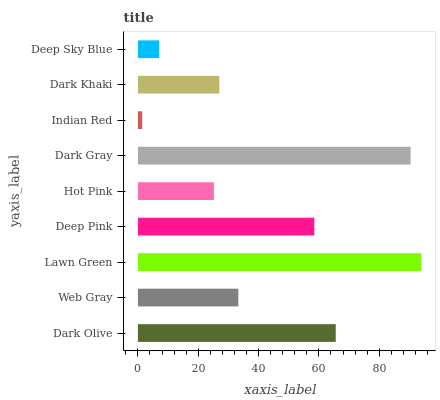Is Indian Red the minimum?
Answer yes or no. Yes. Is Lawn Green the maximum?
Answer yes or no. Yes. Is Web Gray the minimum?
Answer yes or no. No. Is Web Gray the maximum?
Answer yes or no. No. Is Dark Olive greater than Web Gray?
Answer yes or no. Yes. Is Web Gray less than Dark Olive?
Answer yes or no. Yes. Is Web Gray greater than Dark Olive?
Answer yes or no. No. Is Dark Olive less than Web Gray?
Answer yes or no. No. Is Web Gray the high median?
Answer yes or no. Yes. Is Web Gray the low median?
Answer yes or no. Yes. Is Lawn Green the high median?
Answer yes or no. No. Is Indian Red the low median?
Answer yes or no. No. 